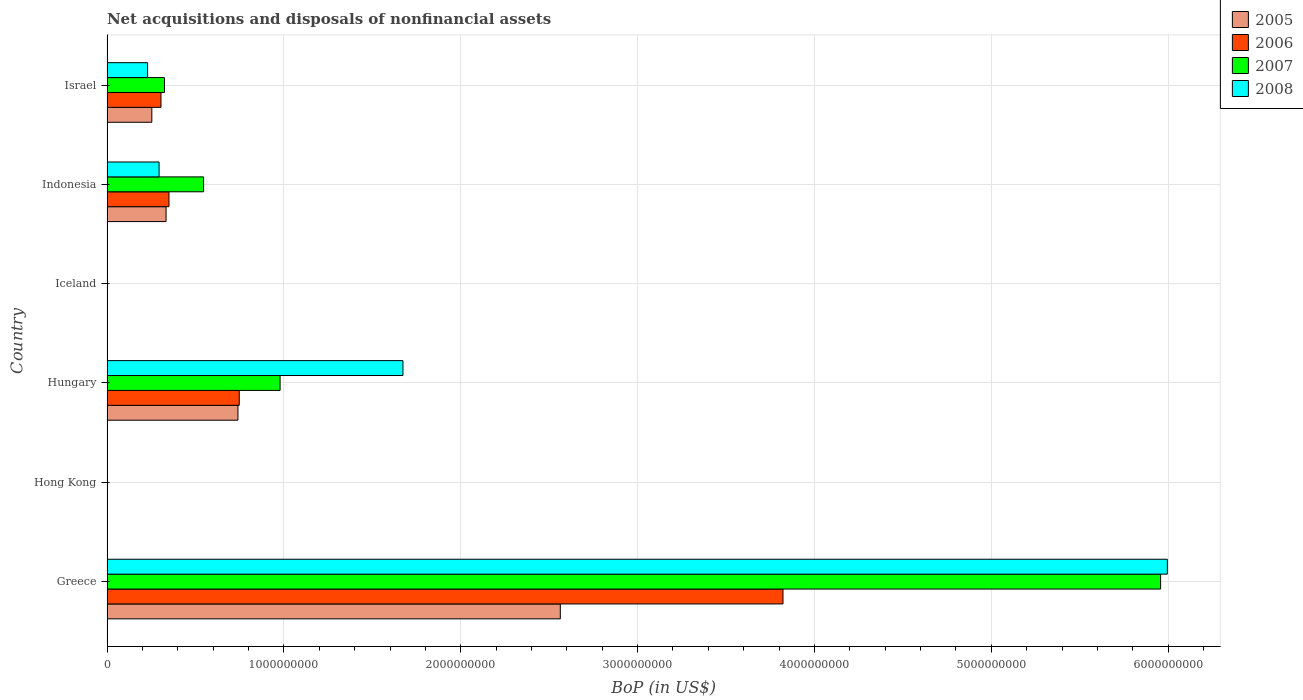Are the number of bars on each tick of the Y-axis equal?
Your answer should be compact. No. How many bars are there on the 4th tick from the top?
Make the answer very short. 4. How many bars are there on the 5th tick from the bottom?
Provide a succinct answer. 4. What is the label of the 5th group of bars from the top?
Ensure brevity in your answer.  Hong Kong. In how many cases, is the number of bars for a given country not equal to the number of legend labels?
Ensure brevity in your answer.  2. What is the Balance of Payments in 2008 in Indonesia?
Your response must be concise. 2.94e+08. Across all countries, what is the maximum Balance of Payments in 2005?
Provide a succinct answer. 2.56e+09. In which country was the Balance of Payments in 2008 maximum?
Make the answer very short. Greece. What is the total Balance of Payments in 2008 in the graph?
Ensure brevity in your answer.  8.19e+09. What is the difference between the Balance of Payments in 2005 in Greece and that in Israel?
Keep it short and to the point. 2.31e+09. What is the difference between the Balance of Payments in 2006 in Greece and the Balance of Payments in 2007 in Iceland?
Make the answer very short. 3.82e+09. What is the average Balance of Payments in 2008 per country?
Give a very brief answer. 1.37e+09. What is the difference between the Balance of Payments in 2006 and Balance of Payments in 2008 in Israel?
Provide a short and direct response. 7.55e+07. In how many countries, is the Balance of Payments in 2006 greater than 3200000000 US$?
Give a very brief answer. 1. What is the ratio of the Balance of Payments in 2007 in Greece to that in Israel?
Provide a succinct answer. 18.33. Is the Balance of Payments in 2007 in Hungary less than that in Israel?
Give a very brief answer. No. What is the difference between the highest and the second highest Balance of Payments in 2007?
Give a very brief answer. 4.98e+09. What is the difference between the highest and the lowest Balance of Payments in 2007?
Provide a succinct answer. 5.96e+09. Is the sum of the Balance of Payments in 2005 in Greece and Indonesia greater than the maximum Balance of Payments in 2006 across all countries?
Ensure brevity in your answer.  No. Is it the case that in every country, the sum of the Balance of Payments in 2005 and Balance of Payments in 2006 is greater than the sum of Balance of Payments in 2008 and Balance of Payments in 2007?
Your response must be concise. No. Is it the case that in every country, the sum of the Balance of Payments in 2008 and Balance of Payments in 2006 is greater than the Balance of Payments in 2005?
Provide a short and direct response. No. How many bars are there?
Keep it short and to the point. 16. Are all the bars in the graph horizontal?
Make the answer very short. Yes. How many countries are there in the graph?
Provide a short and direct response. 6. What is the difference between two consecutive major ticks on the X-axis?
Offer a terse response. 1.00e+09. Where does the legend appear in the graph?
Your answer should be very brief. Top right. How are the legend labels stacked?
Make the answer very short. Vertical. What is the title of the graph?
Ensure brevity in your answer.  Net acquisitions and disposals of nonfinancial assets. What is the label or title of the X-axis?
Give a very brief answer. BoP (in US$). What is the label or title of the Y-axis?
Offer a very short reply. Country. What is the BoP (in US$) of 2005 in Greece?
Offer a very short reply. 2.56e+09. What is the BoP (in US$) of 2006 in Greece?
Offer a terse response. 3.82e+09. What is the BoP (in US$) in 2007 in Greece?
Your answer should be compact. 5.96e+09. What is the BoP (in US$) of 2008 in Greece?
Ensure brevity in your answer.  6.00e+09. What is the BoP (in US$) in 2007 in Hong Kong?
Give a very brief answer. 0. What is the BoP (in US$) of 2008 in Hong Kong?
Keep it short and to the point. 0. What is the BoP (in US$) in 2005 in Hungary?
Keep it short and to the point. 7.40e+08. What is the BoP (in US$) in 2006 in Hungary?
Provide a succinct answer. 7.48e+08. What is the BoP (in US$) of 2007 in Hungary?
Give a very brief answer. 9.79e+08. What is the BoP (in US$) in 2008 in Hungary?
Your answer should be very brief. 1.67e+09. What is the BoP (in US$) of 2005 in Iceland?
Your answer should be compact. 0. What is the BoP (in US$) of 2005 in Indonesia?
Your answer should be very brief. 3.34e+08. What is the BoP (in US$) of 2006 in Indonesia?
Your answer should be compact. 3.50e+08. What is the BoP (in US$) in 2007 in Indonesia?
Your response must be concise. 5.46e+08. What is the BoP (in US$) in 2008 in Indonesia?
Your answer should be very brief. 2.94e+08. What is the BoP (in US$) in 2005 in Israel?
Keep it short and to the point. 2.53e+08. What is the BoP (in US$) of 2006 in Israel?
Provide a short and direct response. 3.05e+08. What is the BoP (in US$) of 2007 in Israel?
Offer a very short reply. 3.25e+08. What is the BoP (in US$) of 2008 in Israel?
Offer a very short reply. 2.30e+08. Across all countries, what is the maximum BoP (in US$) of 2005?
Your response must be concise. 2.56e+09. Across all countries, what is the maximum BoP (in US$) of 2006?
Offer a very short reply. 3.82e+09. Across all countries, what is the maximum BoP (in US$) in 2007?
Your response must be concise. 5.96e+09. Across all countries, what is the maximum BoP (in US$) in 2008?
Offer a very short reply. 6.00e+09. Across all countries, what is the minimum BoP (in US$) of 2005?
Make the answer very short. 0. Across all countries, what is the minimum BoP (in US$) of 2006?
Your answer should be compact. 0. Across all countries, what is the minimum BoP (in US$) of 2008?
Offer a terse response. 0. What is the total BoP (in US$) in 2005 in the graph?
Provide a succinct answer. 3.89e+09. What is the total BoP (in US$) in 2006 in the graph?
Give a very brief answer. 5.23e+09. What is the total BoP (in US$) in 2007 in the graph?
Your answer should be compact. 7.81e+09. What is the total BoP (in US$) of 2008 in the graph?
Provide a short and direct response. 8.19e+09. What is the difference between the BoP (in US$) in 2005 in Greece and that in Hungary?
Give a very brief answer. 1.82e+09. What is the difference between the BoP (in US$) in 2006 in Greece and that in Hungary?
Ensure brevity in your answer.  3.07e+09. What is the difference between the BoP (in US$) of 2007 in Greece and that in Hungary?
Your answer should be very brief. 4.98e+09. What is the difference between the BoP (in US$) of 2008 in Greece and that in Hungary?
Provide a succinct answer. 4.32e+09. What is the difference between the BoP (in US$) of 2005 in Greece and that in Indonesia?
Ensure brevity in your answer.  2.23e+09. What is the difference between the BoP (in US$) of 2006 in Greece and that in Indonesia?
Provide a short and direct response. 3.47e+09. What is the difference between the BoP (in US$) in 2007 in Greece and that in Indonesia?
Your response must be concise. 5.41e+09. What is the difference between the BoP (in US$) of 2008 in Greece and that in Indonesia?
Give a very brief answer. 5.70e+09. What is the difference between the BoP (in US$) of 2005 in Greece and that in Israel?
Offer a terse response. 2.31e+09. What is the difference between the BoP (in US$) in 2006 in Greece and that in Israel?
Your response must be concise. 3.52e+09. What is the difference between the BoP (in US$) in 2007 in Greece and that in Israel?
Your response must be concise. 5.63e+09. What is the difference between the BoP (in US$) in 2008 in Greece and that in Israel?
Offer a very short reply. 5.77e+09. What is the difference between the BoP (in US$) of 2005 in Hungary and that in Indonesia?
Your answer should be very brief. 4.06e+08. What is the difference between the BoP (in US$) in 2006 in Hungary and that in Indonesia?
Your answer should be very brief. 3.97e+08. What is the difference between the BoP (in US$) in 2007 in Hungary and that in Indonesia?
Your answer should be compact. 4.32e+08. What is the difference between the BoP (in US$) of 2008 in Hungary and that in Indonesia?
Keep it short and to the point. 1.38e+09. What is the difference between the BoP (in US$) in 2005 in Hungary and that in Israel?
Your answer should be very brief. 4.87e+08. What is the difference between the BoP (in US$) of 2006 in Hungary and that in Israel?
Your response must be concise. 4.43e+08. What is the difference between the BoP (in US$) of 2007 in Hungary and that in Israel?
Your answer should be very brief. 6.54e+08. What is the difference between the BoP (in US$) of 2008 in Hungary and that in Israel?
Your answer should be compact. 1.44e+09. What is the difference between the BoP (in US$) in 2005 in Indonesia and that in Israel?
Make the answer very short. 8.05e+07. What is the difference between the BoP (in US$) in 2006 in Indonesia and that in Israel?
Provide a succinct answer. 4.52e+07. What is the difference between the BoP (in US$) in 2007 in Indonesia and that in Israel?
Offer a very short reply. 2.21e+08. What is the difference between the BoP (in US$) of 2008 in Indonesia and that in Israel?
Give a very brief answer. 6.49e+07. What is the difference between the BoP (in US$) in 2005 in Greece and the BoP (in US$) in 2006 in Hungary?
Offer a very short reply. 1.82e+09. What is the difference between the BoP (in US$) of 2005 in Greece and the BoP (in US$) of 2007 in Hungary?
Keep it short and to the point. 1.58e+09. What is the difference between the BoP (in US$) of 2005 in Greece and the BoP (in US$) of 2008 in Hungary?
Your response must be concise. 8.90e+08. What is the difference between the BoP (in US$) of 2006 in Greece and the BoP (in US$) of 2007 in Hungary?
Make the answer very short. 2.84e+09. What is the difference between the BoP (in US$) of 2006 in Greece and the BoP (in US$) of 2008 in Hungary?
Offer a very short reply. 2.15e+09. What is the difference between the BoP (in US$) of 2007 in Greece and the BoP (in US$) of 2008 in Hungary?
Give a very brief answer. 4.28e+09. What is the difference between the BoP (in US$) of 2005 in Greece and the BoP (in US$) of 2006 in Indonesia?
Your answer should be compact. 2.21e+09. What is the difference between the BoP (in US$) in 2005 in Greece and the BoP (in US$) in 2007 in Indonesia?
Offer a very short reply. 2.02e+09. What is the difference between the BoP (in US$) in 2005 in Greece and the BoP (in US$) in 2008 in Indonesia?
Your answer should be compact. 2.27e+09. What is the difference between the BoP (in US$) in 2006 in Greece and the BoP (in US$) in 2007 in Indonesia?
Your response must be concise. 3.28e+09. What is the difference between the BoP (in US$) of 2006 in Greece and the BoP (in US$) of 2008 in Indonesia?
Offer a terse response. 3.53e+09. What is the difference between the BoP (in US$) in 2007 in Greece and the BoP (in US$) in 2008 in Indonesia?
Your response must be concise. 5.66e+09. What is the difference between the BoP (in US$) in 2005 in Greece and the BoP (in US$) in 2006 in Israel?
Offer a terse response. 2.26e+09. What is the difference between the BoP (in US$) of 2005 in Greece and the BoP (in US$) of 2007 in Israel?
Your answer should be very brief. 2.24e+09. What is the difference between the BoP (in US$) in 2005 in Greece and the BoP (in US$) in 2008 in Israel?
Keep it short and to the point. 2.33e+09. What is the difference between the BoP (in US$) of 2006 in Greece and the BoP (in US$) of 2007 in Israel?
Provide a succinct answer. 3.50e+09. What is the difference between the BoP (in US$) of 2006 in Greece and the BoP (in US$) of 2008 in Israel?
Ensure brevity in your answer.  3.59e+09. What is the difference between the BoP (in US$) of 2007 in Greece and the BoP (in US$) of 2008 in Israel?
Ensure brevity in your answer.  5.73e+09. What is the difference between the BoP (in US$) in 2005 in Hungary and the BoP (in US$) in 2006 in Indonesia?
Your answer should be compact. 3.90e+08. What is the difference between the BoP (in US$) in 2005 in Hungary and the BoP (in US$) in 2007 in Indonesia?
Make the answer very short. 1.94e+08. What is the difference between the BoP (in US$) of 2005 in Hungary and the BoP (in US$) of 2008 in Indonesia?
Offer a very short reply. 4.46e+08. What is the difference between the BoP (in US$) in 2006 in Hungary and the BoP (in US$) in 2007 in Indonesia?
Offer a terse response. 2.01e+08. What is the difference between the BoP (in US$) of 2006 in Hungary and the BoP (in US$) of 2008 in Indonesia?
Provide a succinct answer. 4.53e+08. What is the difference between the BoP (in US$) in 2007 in Hungary and the BoP (in US$) in 2008 in Indonesia?
Your answer should be very brief. 6.84e+08. What is the difference between the BoP (in US$) of 2005 in Hungary and the BoP (in US$) of 2006 in Israel?
Your answer should be compact. 4.35e+08. What is the difference between the BoP (in US$) in 2005 in Hungary and the BoP (in US$) in 2007 in Israel?
Offer a terse response. 4.15e+08. What is the difference between the BoP (in US$) in 2005 in Hungary and the BoP (in US$) in 2008 in Israel?
Keep it short and to the point. 5.11e+08. What is the difference between the BoP (in US$) in 2006 in Hungary and the BoP (in US$) in 2007 in Israel?
Offer a terse response. 4.23e+08. What is the difference between the BoP (in US$) of 2006 in Hungary and the BoP (in US$) of 2008 in Israel?
Ensure brevity in your answer.  5.18e+08. What is the difference between the BoP (in US$) of 2007 in Hungary and the BoP (in US$) of 2008 in Israel?
Offer a terse response. 7.49e+08. What is the difference between the BoP (in US$) of 2005 in Indonesia and the BoP (in US$) of 2006 in Israel?
Offer a very short reply. 2.88e+07. What is the difference between the BoP (in US$) of 2005 in Indonesia and the BoP (in US$) of 2007 in Israel?
Your answer should be compact. 9.02e+06. What is the difference between the BoP (in US$) in 2005 in Indonesia and the BoP (in US$) in 2008 in Israel?
Your response must be concise. 1.04e+08. What is the difference between the BoP (in US$) of 2006 in Indonesia and the BoP (in US$) of 2007 in Israel?
Ensure brevity in your answer.  2.54e+07. What is the difference between the BoP (in US$) in 2006 in Indonesia and the BoP (in US$) in 2008 in Israel?
Keep it short and to the point. 1.21e+08. What is the difference between the BoP (in US$) of 2007 in Indonesia and the BoP (in US$) of 2008 in Israel?
Ensure brevity in your answer.  3.17e+08. What is the average BoP (in US$) of 2005 per country?
Provide a short and direct response. 6.48e+08. What is the average BoP (in US$) in 2006 per country?
Your response must be concise. 8.71e+08. What is the average BoP (in US$) in 2007 per country?
Offer a very short reply. 1.30e+09. What is the average BoP (in US$) in 2008 per country?
Your answer should be very brief. 1.37e+09. What is the difference between the BoP (in US$) of 2005 and BoP (in US$) of 2006 in Greece?
Keep it short and to the point. -1.26e+09. What is the difference between the BoP (in US$) of 2005 and BoP (in US$) of 2007 in Greece?
Offer a terse response. -3.39e+09. What is the difference between the BoP (in US$) in 2005 and BoP (in US$) in 2008 in Greece?
Offer a very short reply. -3.43e+09. What is the difference between the BoP (in US$) in 2006 and BoP (in US$) in 2007 in Greece?
Ensure brevity in your answer.  -2.14e+09. What is the difference between the BoP (in US$) of 2006 and BoP (in US$) of 2008 in Greece?
Give a very brief answer. -2.17e+09. What is the difference between the BoP (in US$) of 2007 and BoP (in US$) of 2008 in Greece?
Offer a very short reply. -3.82e+07. What is the difference between the BoP (in US$) of 2005 and BoP (in US$) of 2006 in Hungary?
Your answer should be very brief. -7.44e+06. What is the difference between the BoP (in US$) in 2005 and BoP (in US$) in 2007 in Hungary?
Ensure brevity in your answer.  -2.38e+08. What is the difference between the BoP (in US$) in 2005 and BoP (in US$) in 2008 in Hungary?
Your response must be concise. -9.33e+08. What is the difference between the BoP (in US$) in 2006 and BoP (in US$) in 2007 in Hungary?
Ensure brevity in your answer.  -2.31e+08. What is the difference between the BoP (in US$) in 2006 and BoP (in US$) in 2008 in Hungary?
Provide a succinct answer. -9.26e+08. What is the difference between the BoP (in US$) of 2007 and BoP (in US$) of 2008 in Hungary?
Provide a succinct answer. -6.95e+08. What is the difference between the BoP (in US$) in 2005 and BoP (in US$) in 2006 in Indonesia?
Your response must be concise. -1.64e+07. What is the difference between the BoP (in US$) in 2005 and BoP (in US$) in 2007 in Indonesia?
Keep it short and to the point. -2.12e+08. What is the difference between the BoP (in US$) of 2005 and BoP (in US$) of 2008 in Indonesia?
Provide a short and direct response. 3.95e+07. What is the difference between the BoP (in US$) in 2006 and BoP (in US$) in 2007 in Indonesia?
Make the answer very short. -1.96e+08. What is the difference between the BoP (in US$) in 2006 and BoP (in US$) in 2008 in Indonesia?
Keep it short and to the point. 5.59e+07. What is the difference between the BoP (in US$) in 2007 and BoP (in US$) in 2008 in Indonesia?
Provide a succinct answer. 2.52e+08. What is the difference between the BoP (in US$) of 2005 and BoP (in US$) of 2006 in Israel?
Keep it short and to the point. -5.17e+07. What is the difference between the BoP (in US$) in 2005 and BoP (in US$) in 2007 in Israel?
Give a very brief answer. -7.15e+07. What is the difference between the BoP (in US$) of 2005 and BoP (in US$) of 2008 in Israel?
Provide a short and direct response. 2.38e+07. What is the difference between the BoP (in US$) of 2006 and BoP (in US$) of 2007 in Israel?
Ensure brevity in your answer.  -1.98e+07. What is the difference between the BoP (in US$) of 2006 and BoP (in US$) of 2008 in Israel?
Offer a very short reply. 7.55e+07. What is the difference between the BoP (in US$) in 2007 and BoP (in US$) in 2008 in Israel?
Keep it short and to the point. 9.53e+07. What is the ratio of the BoP (in US$) of 2005 in Greece to that in Hungary?
Offer a very short reply. 3.46. What is the ratio of the BoP (in US$) in 2006 in Greece to that in Hungary?
Your answer should be very brief. 5.11. What is the ratio of the BoP (in US$) of 2007 in Greece to that in Hungary?
Your answer should be very brief. 6.09. What is the ratio of the BoP (in US$) of 2008 in Greece to that in Hungary?
Make the answer very short. 3.58. What is the ratio of the BoP (in US$) of 2005 in Greece to that in Indonesia?
Give a very brief answer. 7.68. What is the ratio of the BoP (in US$) in 2006 in Greece to that in Indonesia?
Offer a terse response. 10.91. What is the ratio of the BoP (in US$) in 2007 in Greece to that in Indonesia?
Offer a terse response. 10.91. What is the ratio of the BoP (in US$) in 2008 in Greece to that in Indonesia?
Provide a succinct answer. 20.36. What is the ratio of the BoP (in US$) of 2005 in Greece to that in Israel?
Offer a very short reply. 10.11. What is the ratio of the BoP (in US$) in 2006 in Greece to that in Israel?
Offer a terse response. 12.53. What is the ratio of the BoP (in US$) in 2007 in Greece to that in Israel?
Provide a succinct answer. 18.33. What is the ratio of the BoP (in US$) of 2008 in Greece to that in Israel?
Ensure brevity in your answer.  26.11. What is the ratio of the BoP (in US$) of 2005 in Hungary to that in Indonesia?
Your response must be concise. 2.22. What is the ratio of the BoP (in US$) in 2006 in Hungary to that in Indonesia?
Provide a succinct answer. 2.13. What is the ratio of the BoP (in US$) of 2007 in Hungary to that in Indonesia?
Your answer should be compact. 1.79. What is the ratio of the BoP (in US$) of 2008 in Hungary to that in Indonesia?
Provide a short and direct response. 5.68. What is the ratio of the BoP (in US$) of 2005 in Hungary to that in Israel?
Your answer should be very brief. 2.92. What is the ratio of the BoP (in US$) in 2006 in Hungary to that in Israel?
Provide a succinct answer. 2.45. What is the ratio of the BoP (in US$) in 2007 in Hungary to that in Israel?
Make the answer very short. 3.01. What is the ratio of the BoP (in US$) of 2008 in Hungary to that in Israel?
Ensure brevity in your answer.  7.29. What is the ratio of the BoP (in US$) in 2005 in Indonesia to that in Israel?
Give a very brief answer. 1.32. What is the ratio of the BoP (in US$) of 2006 in Indonesia to that in Israel?
Ensure brevity in your answer.  1.15. What is the ratio of the BoP (in US$) of 2007 in Indonesia to that in Israel?
Your response must be concise. 1.68. What is the ratio of the BoP (in US$) in 2008 in Indonesia to that in Israel?
Provide a short and direct response. 1.28. What is the difference between the highest and the second highest BoP (in US$) in 2005?
Offer a very short reply. 1.82e+09. What is the difference between the highest and the second highest BoP (in US$) of 2006?
Your answer should be very brief. 3.07e+09. What is the difference between the highest and the second highest BoP (in US$) in 2007?
Provide a succinct answer. 4.98e+09. What is the difference between the highest and the second highest BoP (in US$) in 2008?
Provide a short and direct response. 4.32e+09. What is the difference between the highest and the lowest BoP (in US$) of 2005?
Ensure brevity in your answer.  2.56e+09. What is the difference between the highest and the lowest BoP (in US$) in 2006?
Your answer should be compact. 3.82e+09. What is the difference between the highest and the lowest BoP (in US$) of 2007?
Ensure brevity in your answer.  5.96e+09. What is the difference between the highest and the lowest BoP (in US$) in 2008?
Offer a very short reply. 6.00e+09. 